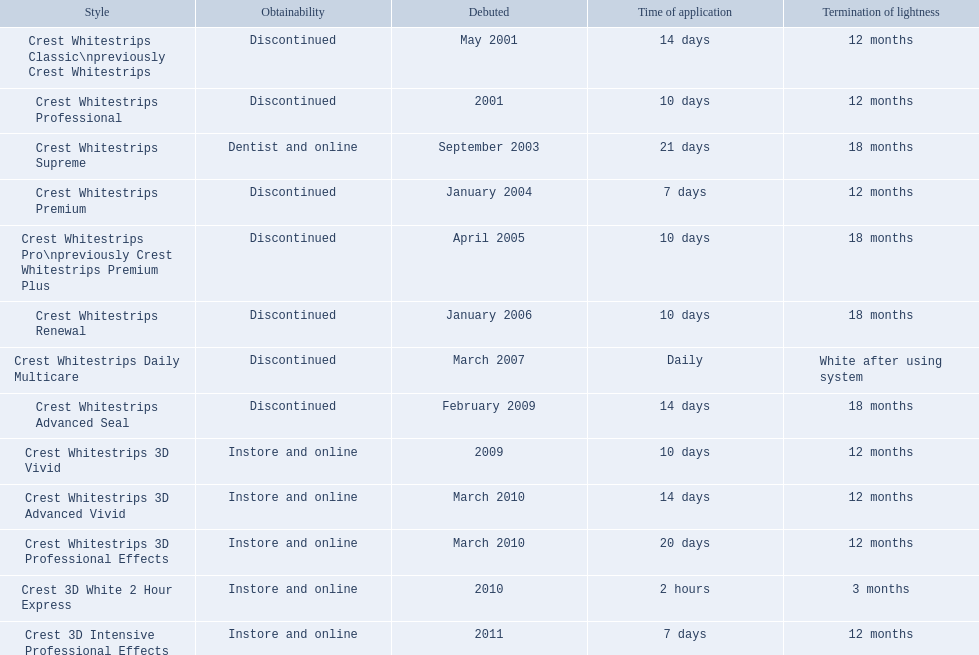What year did crest come out with crest white strips 3d vivid? 2009. Which crest product was also introduced he same year, but is now discontinued? Crest Whitestrips Advanced Seal. 